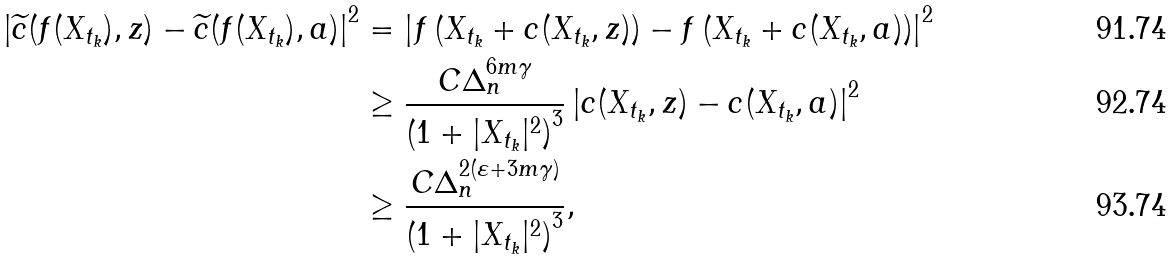<formula> <loc_0><loc_0><loc_500><loc_500>\left | \widetilde { c } ( f ( X _ { t _ { k } } ) , z ) - \widetilde { c } ( f ( X _ { t _ { k } } ) , a ) \right | ^ { 2 } & = \left | f \left ( X _ { t _ { k } } + c ( X _ { t _ { k } } , z ) \right ) - f \left ( X _ { t _ { k } } + c ( X _ { t _ { k } } , a ) \right ) \right | ^ { 2 } \\ & \geq \frac { C \Delta _ { n } ^ { 6 m \gamma } } { \left ( 1 + | X _ { t _ { k } } | ^ { 2 } \right ) ^ { 3 } } \left | c ( X _ { t _ { k } } , z ) - c ( X _ { t _ { k } } , a ) \right | ^ { 2 } \\ & \geq \frac { C \Delta _ { n } ^ { 2 ( \varepsilon + 3 m \gamma ) } } { \left ( 1 + | X _ { t _ { k } } | ^ { 2 } \right ) ^ { 3 } } ,</formula> 